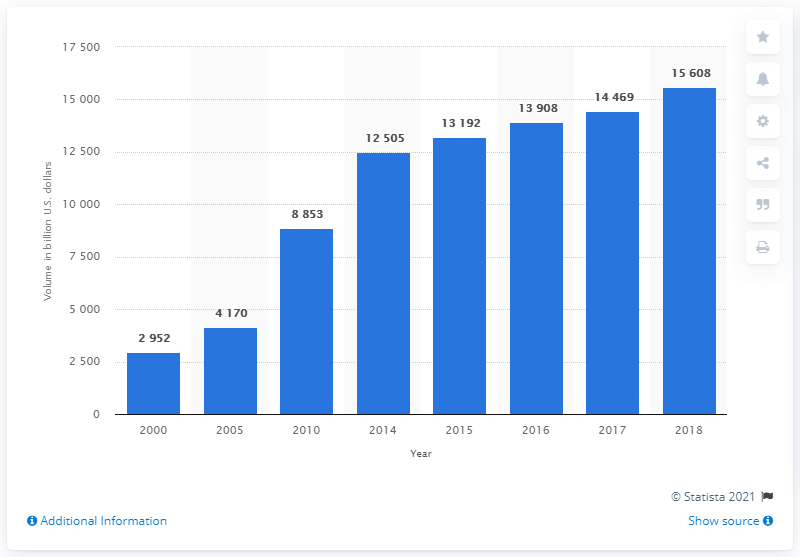Give some essential details in this illustration. In 2018, the volume of treasury securities outstanding in the United States was 15,608.... 